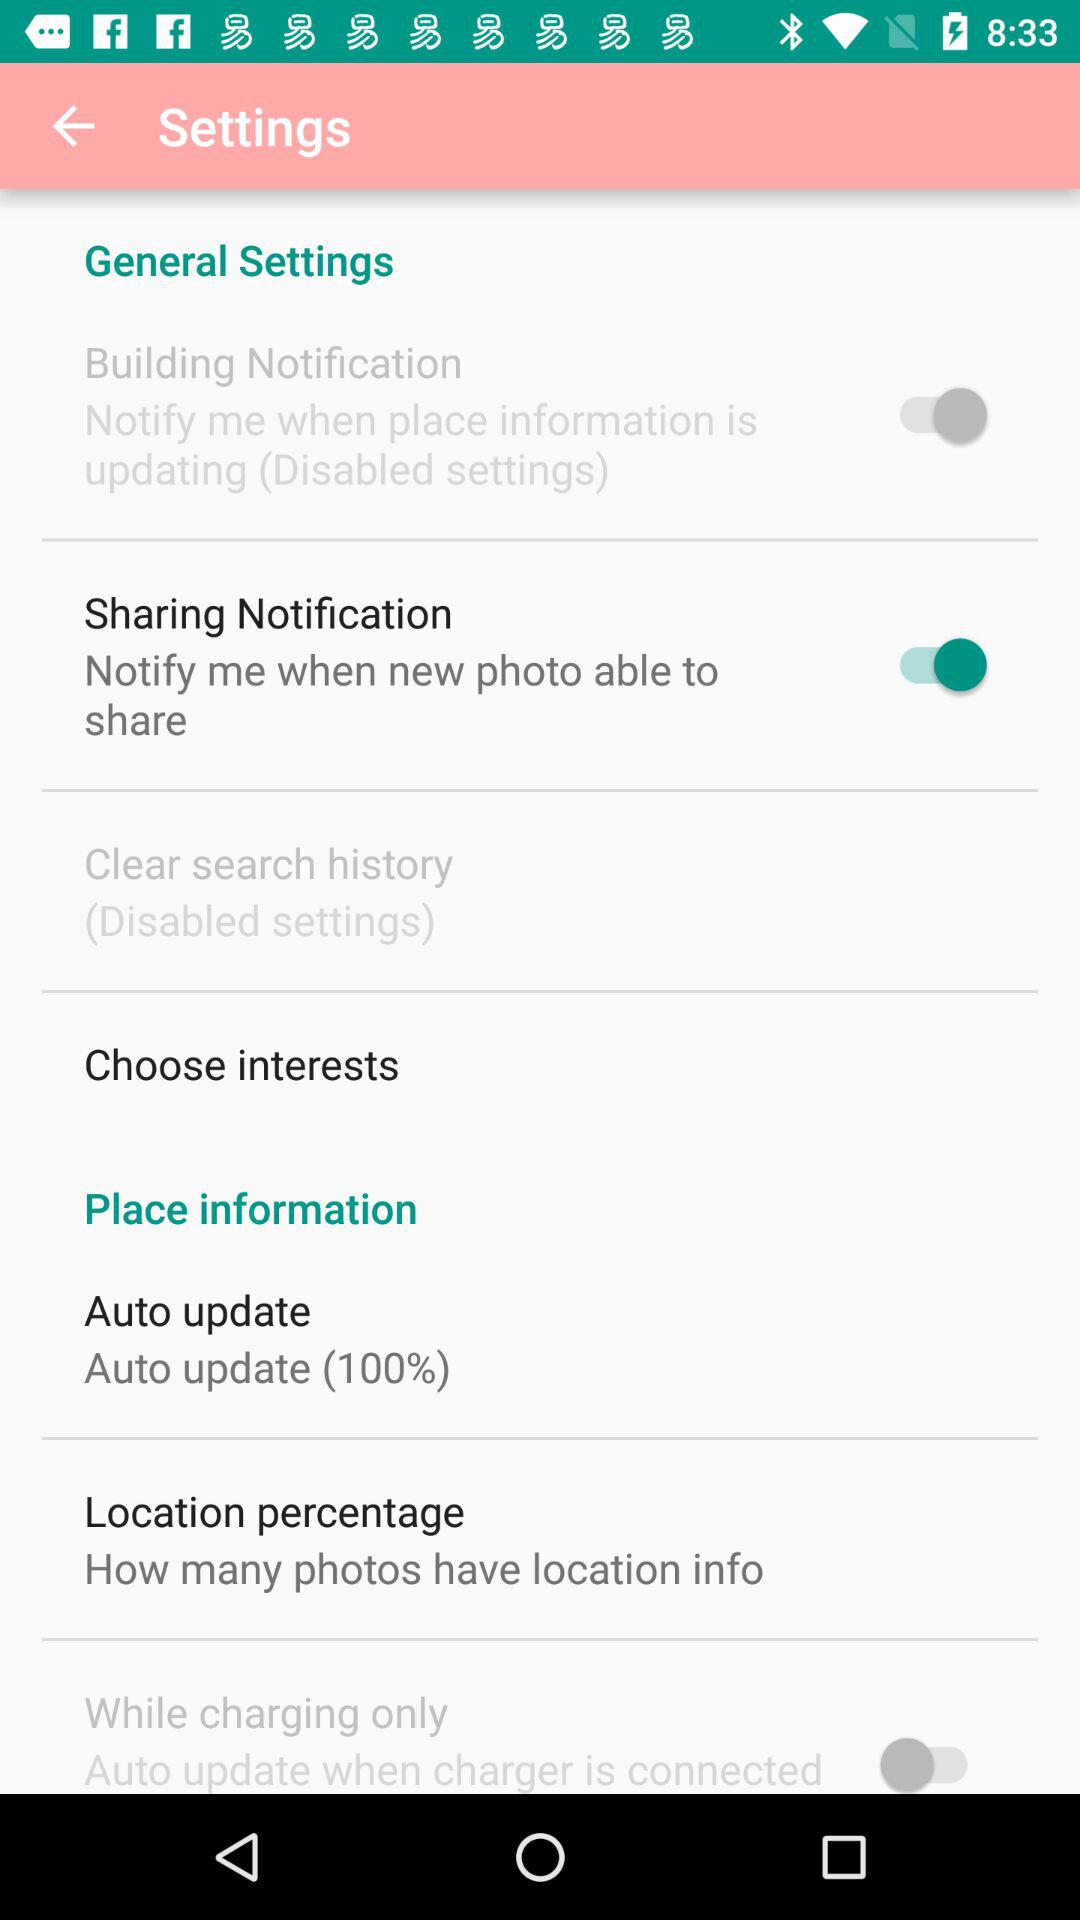What general settings are on? The general setting is on for "Sharing Notification". 